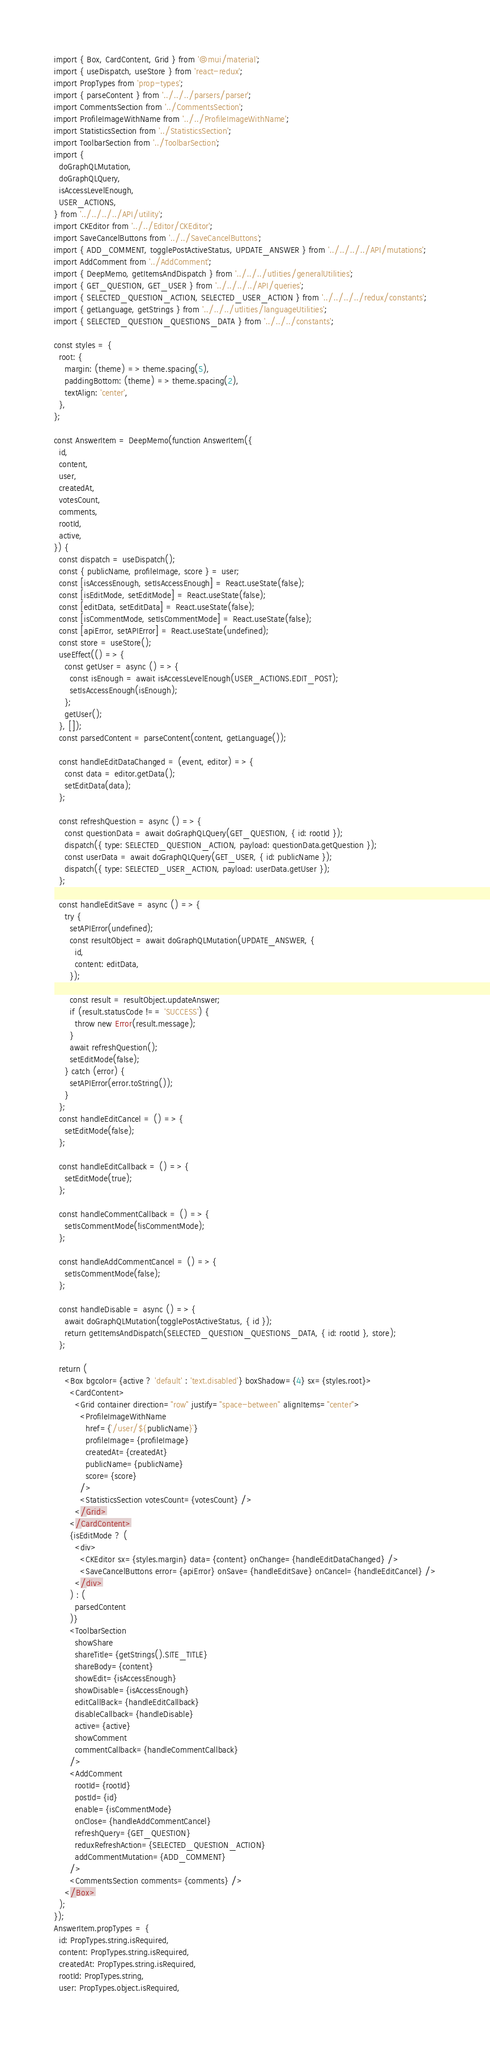<code> <loc_0><loc_0><loc_500><loc_500><_JavaScript_>import { Box, CardContent, Grid } from '@mui/material';
import { useDispatch, useStore } from 'react-redux';
import PropTypes from 'prop-types';
import { parseContent } from '../../../parsers/parser';
import CommentsSection from '../CommentsSection';
import ProfileImageWithName from '../../ProfileImageWithName';
import StatisticsSection from '../StatisticsSection';
import ToolbarSection from '../ToolbarSection';
import {
  doGraphQLMutation,
  doGraphQLQuery,
  isAccessLevelEnough,
  USER_ACTIONS,
} from '../../../../API/utility';
import CKEditor from '../../Editor/CKEditor';
import SaveCancelButtons from '../../SaveCancelButtons';
import { ADD_COMMENT, togglePostActiveStatus, UPDATE_ANSWER } from '../../../../API/mutations';
import AddComment from '../AddComment';
import { DeepMemo, getItemsAndDispatch } from '../../../utlities/generalUtilities';
import { GET_QUESTION, GET_USER } from '../../../../API/queries';
import { SELECTED_QUESTION_ACTION, SELECTED_USER_ACTION } from '../../../../redux/constants';
import { getLanguage, getStrings } from '../../../utlities/languageUtilities';
import { SELECTED_QUESTION_QUESTIONS_DATA } from '../../../constants';

const styles = {
  root: {
    margin: (theme) => theme.spacing(5),
    paddingBottom: (theme) => theme.spacing(2),
    textAlign: 'center',
  },
};

const AnswerItem = DeepMemo(function AnswerItem({
  id,
  content,
  user,
  createdAt,
  votesCount,
  comments,
  rootId,
  active,
}) {
  const dispatch = useDispatch();
  const { publicName, profileImage, score } = user;
  const [isAccessEnough, setIsAccessEnough] = React.useState(false);
  const [isEditMode, setEditMode] = React.useState(false);
  const [editData, setEditData] = React.useState(false);
  const [isCommentMode, setIsCommentMode] = React.useState(false);
  const [apiError, setAPIError] = React.useState(undefined);
  const store = useStore();
  useEffect(() => {
    const getUser = async () => {
      const isEnough = await isAccessLevelEnough(USER_ACTIONS.EDIT_POST);
      setIsAccessEnough(isEnough);
    };
    getUser();
  }, []);
  const parsedContent = parseContent(content, getLanguage());

  const handleEditDataChanged = (event, editor) => {
    const data = editor.getData();
    setEditData(data);
  };

  const refreshQuestion = async () => {
    const questionData = await doGraphQLQuery(GET_QUESTION, { id: rootId });
    dispatch({ type: SELECTED_QUESTION_ACTION, payload: questionData.getQuestion });
    const userData = await doGraphQLQuery(GET_USER, { id: publicName });
    dispatch({ type: SELECTED_USER_ACTION, payload: userData.getUser });
  };

  const handleEditSave = async () => {
    try {
      setAPIError(undefined);
      const resultObject = await doGraphQLMutation(UPDATE_ANSWER, {
        id,
        content: editData,
      });

      const result = resultObject.updateAnswer;
      if (result.statusCode !== 'SUCCESS') {
        throw new Error(result.message);
      }
      await refreshQuestion();
      setEditMode(false);
    } catch (error) {
      setAPIError(error.toString());
    }
  };
  const handleEditCancel = () => {
    setEditMode(false);
  };

  const handleEditCallback = () => {
    setEditMode(true);
  };

  const handleCommentCallback = () => {
    setIsCommentMode(!isCommentMode);
  };

  const handleAddCommentCancel = () => {
    setIsCommentMode(false);
  };

  const handleDisable = async () => {
    await doGraphQLMutation(togglePostActiveStatus, { id });
    return getItemsAndDispatch(SELECTED_QUESTION_QUESTIONS_DATA, { id: rootId }, store);
  };

  return (
    <Box bgcolor={active ? 'default' : 'text.disabled'} boxShadow={4} sx={styles.root}>
      <CardContent>
        <Grid container direction="row" justify="space-between" alignItems="center">
          <ProfileImageWithName
            href={`/user/${publicName}`}
            profileImage={profileImage}
            createdAt={createdAt}
            publicName={publicName}
            score={score}
          />
          <StatisticsSection votesCount={votesCount} />
        </Grid>
      </CardContent>
      {isEditMode ? (
        <div>
          <CKEditor sx={styles.margin} data={content} onChange={handleEditDataChanged} />
          <SaveCancelButtons error={apiError} onSave={handleEditSave} onCancel={handleEditCancel} />
        </div>
      ) : (
        parsedContent
      )}
      <ToolbarSection
        showShare
        shareTitle={getStrings().SITE_TITLE}
        shareBody={content}
        showEdit={isAccessEnough}
        showDisable={isAccessEnough}
        editCallBack={handleEditCallback}
        disableCallback={handleDisable}
        active={active}
        showComment
        commentCallback={handleCommentCallback}
      />
      <AddComment
        rootId={rootId}
        postId={id}
        enable={isCommentMode}
        onClose={handleAddCommentCancel}
        refreshQuery={GET_QUESTION}
        reduxRefreshAction={SELECTED_QUESTION_ACTION}
        addCommentMutation={ADD_COMMENT}
      />
      <CommentsSection comments={comments} />
    </Box>
  );
});
AnswerItem.propTypes = {
  id: PropTypes.string.isRequired,
  content: PropTypes.string.isRequired,
  createdAt: PropTypes.string.isRequired,
  rootId: PropTypes.string,
  user: PropTypes.object.isRequired,</code> 